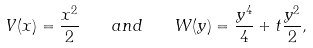<formula> <loc_0><loc_0><loc_500><loc_500>V ( x ) = \frac { x ^ { 2 } } { 2 } \quad a n d \quad W ( y ) = \frac { y ^ { 4 } } { 4 } + t \frac { y ^ { 2 } } { 2 } ,</formula> 